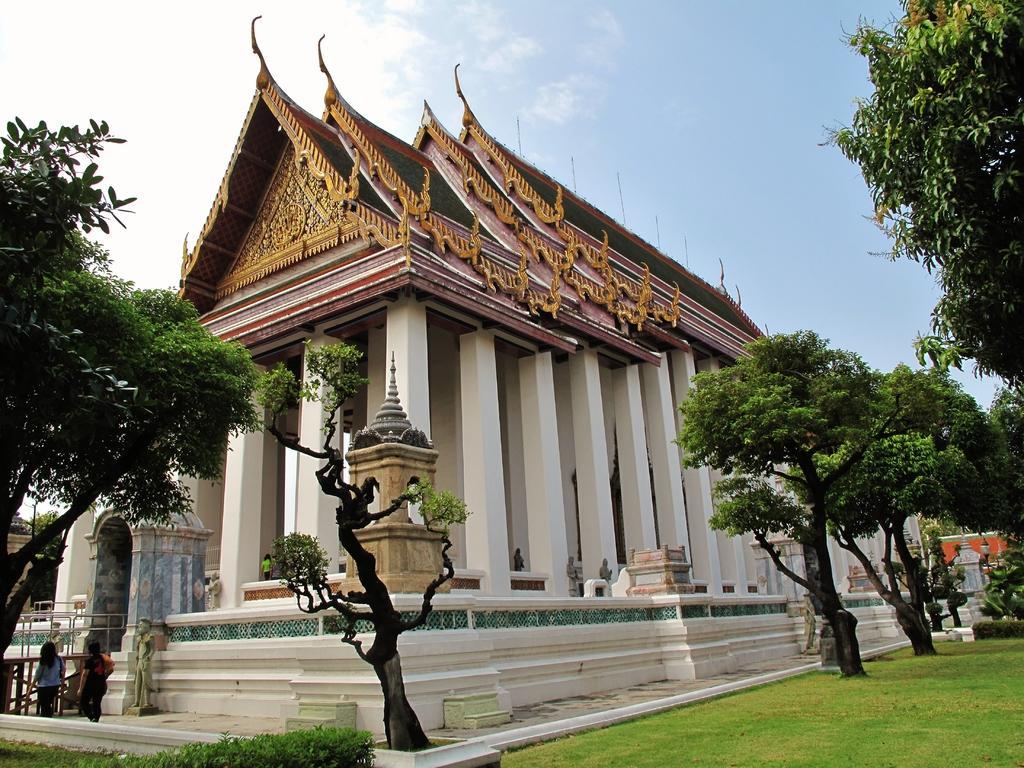Please provide a concise description of this image. In this image, we can see a house. There are a few people, plants and trees. We can also see the ground covered with grass. We can see some pillars and statues. We can also see the sky. 